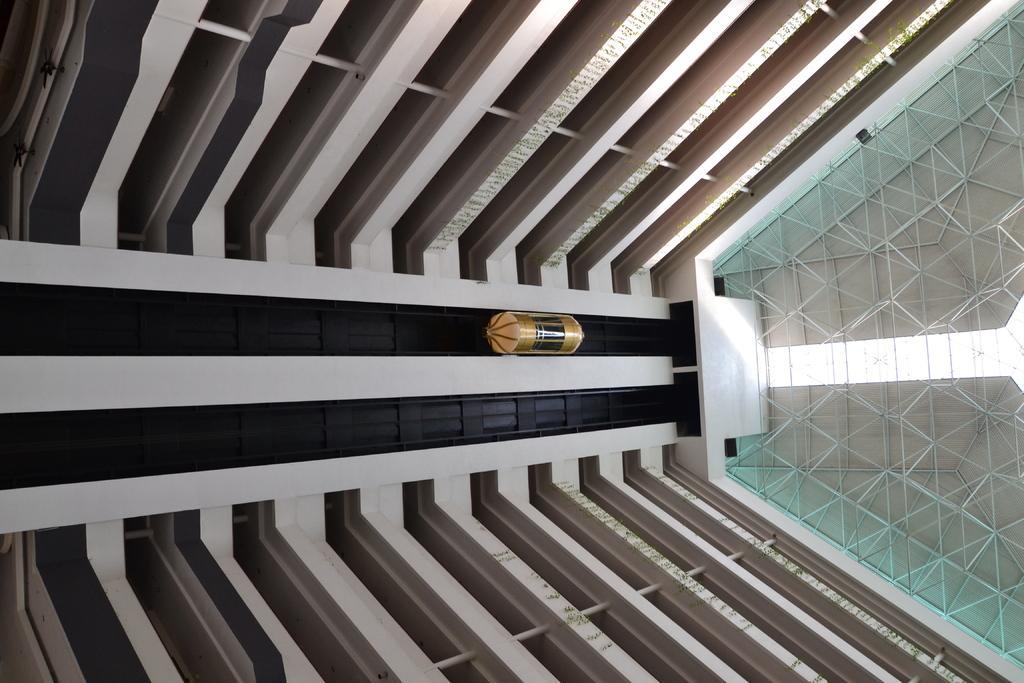Could you give a brief overview of what you see in this image? Here in this picture we can see the inner view of a building and in the middle we can see a lift present over there. 